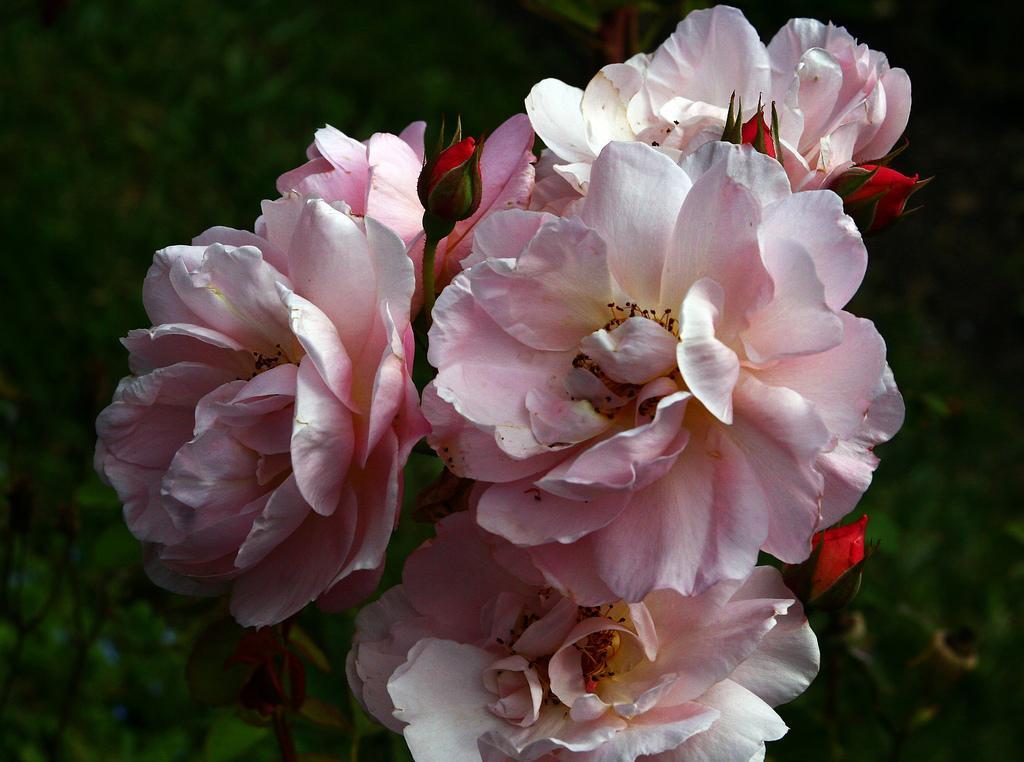Please provide a concise description of this image. In this image, I can see a bunch of rose flowers, which are light pink in color. I can see the flower buds. The background looks blurry. 